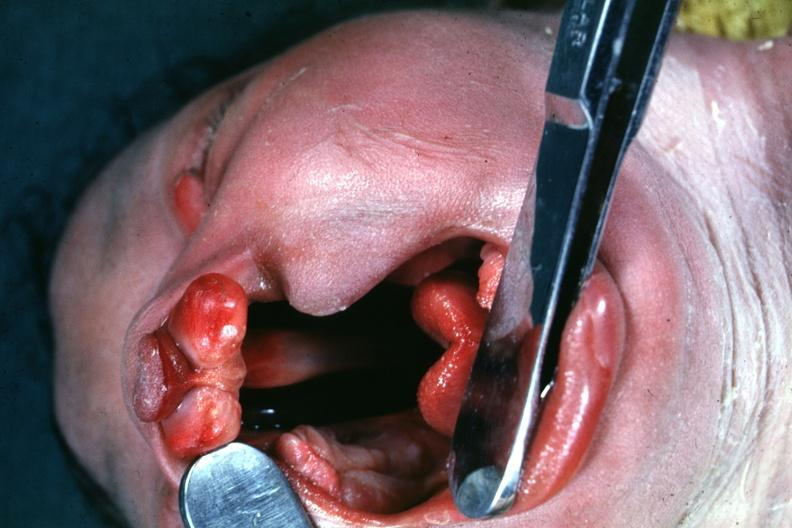does anencephaly show head tilted with mouth?
Answer the question using a single word or phrase. No 